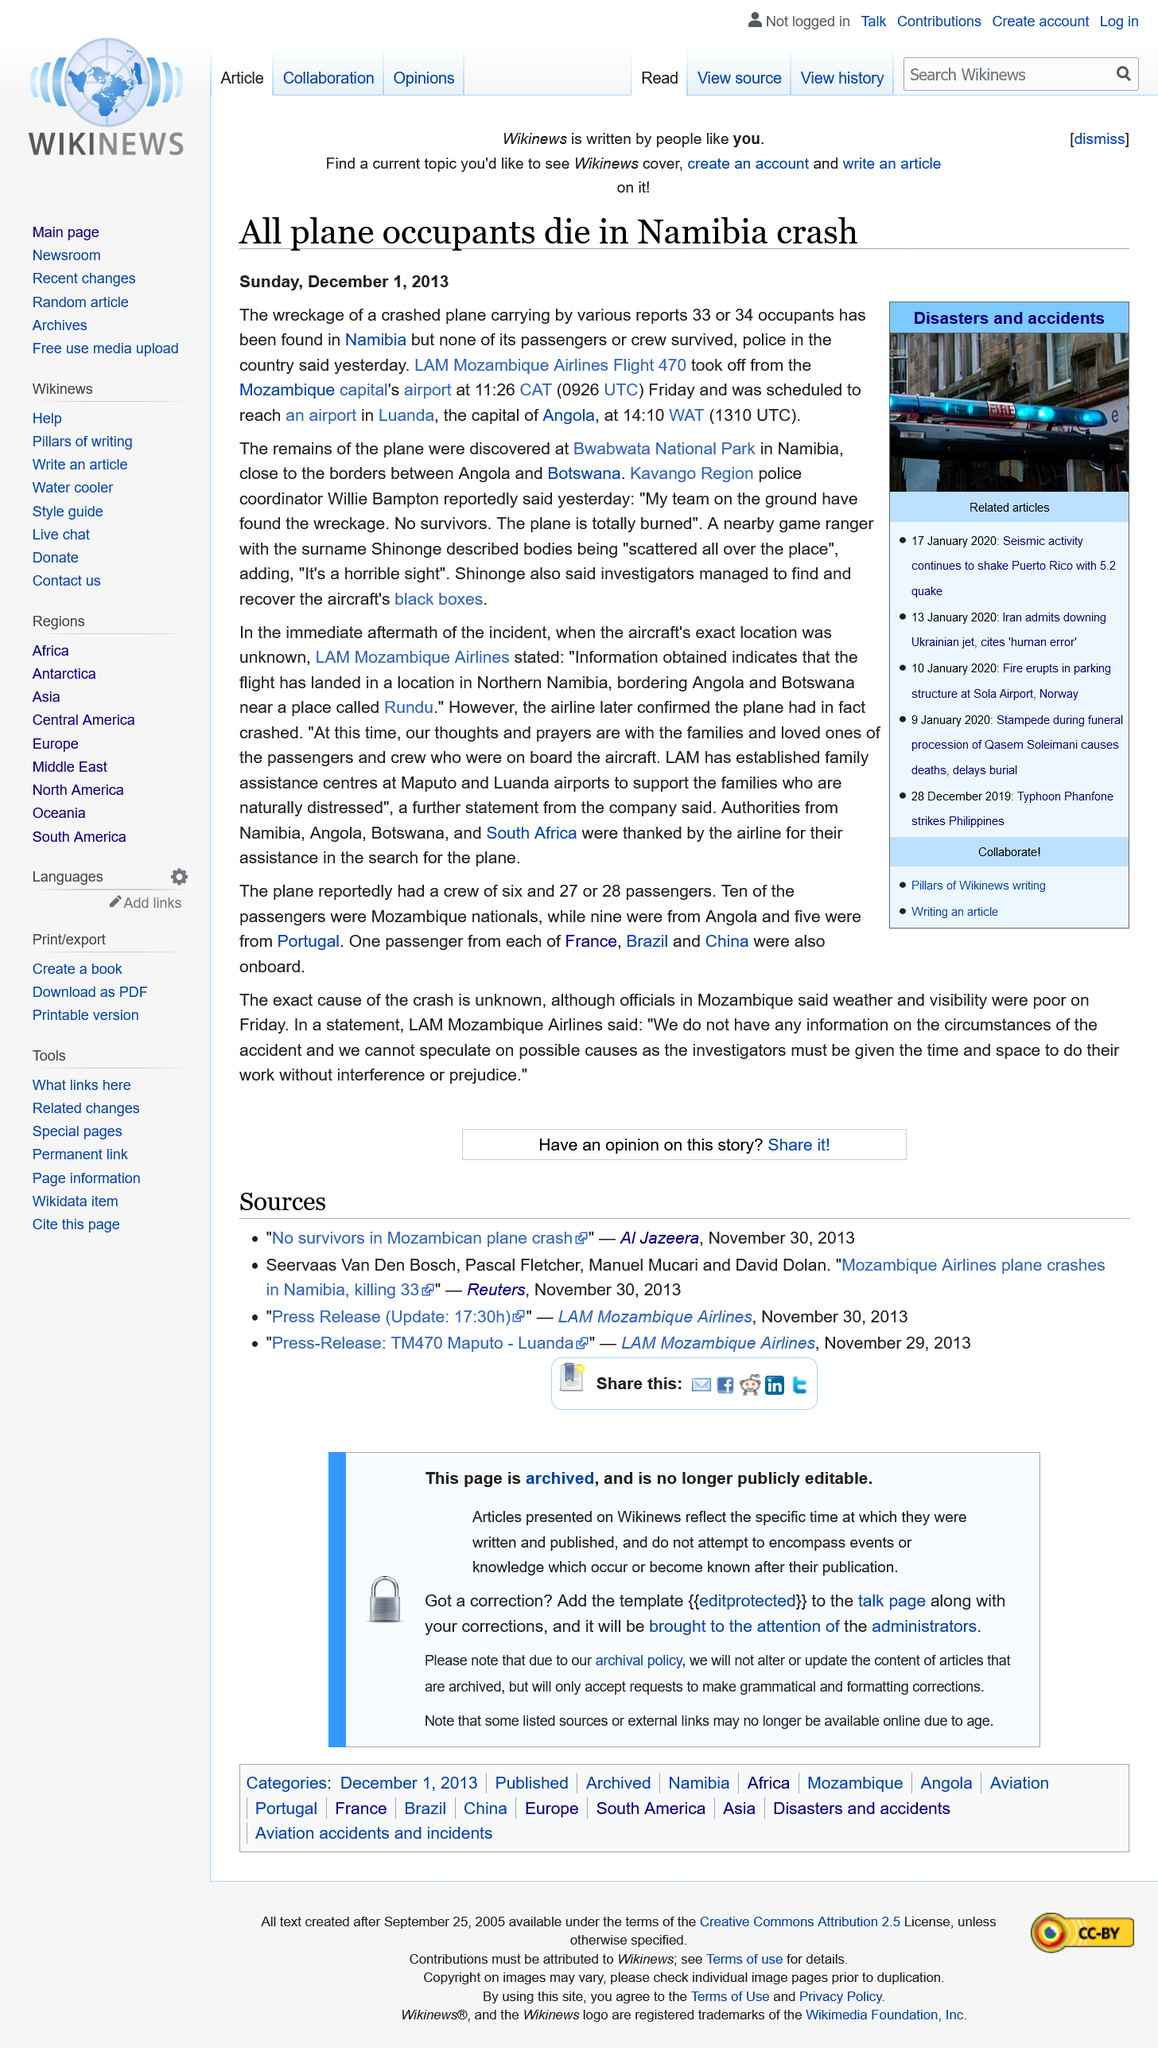Identify some key points in this picture. On Friday, November 29th, 2013, the LAM Mozambique Airlines Flight 470 crash occurred. All plane occupants and passengers or crew members of LAM Mozambique Airlines Flight 470 died upon the aircraft's crash. No one survived the incident. The black box from LAM Mozambique Airlines Flight 470 was successfully recovered by investigators. 